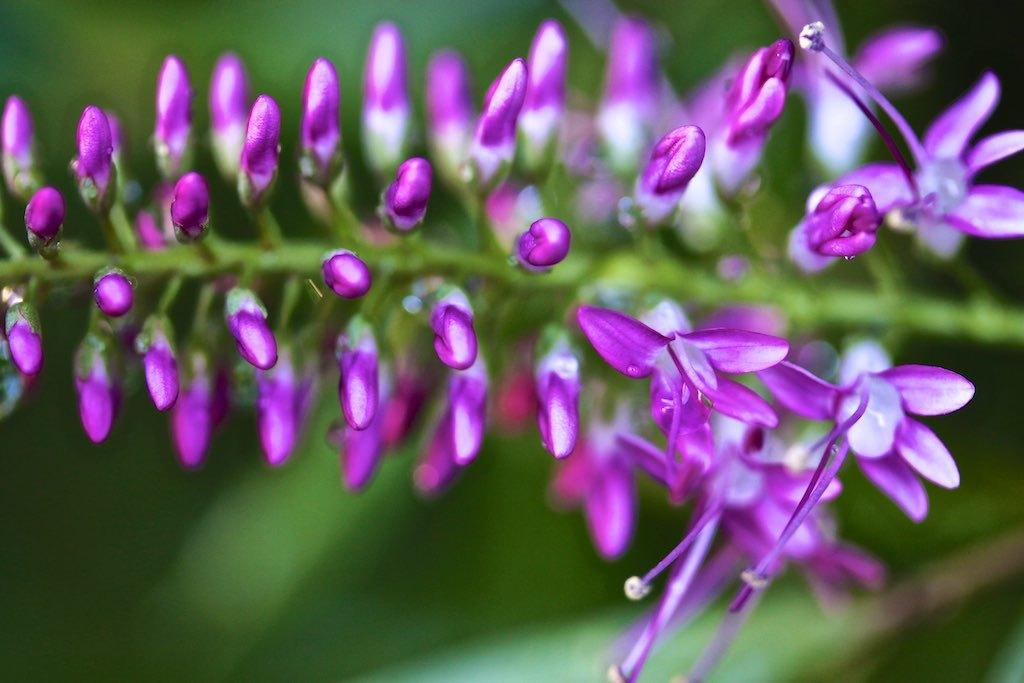What is the main subject in the center of the image? There are flowers and buds in the center of the image. Are there any other objects present in the center of the image? Yes, there are other objects in the center of the image. What color is the background of the image? The background of the image is green in color. What is the sound of people laughing in the image? There is no sound of people laughing in the image, as it is a still image and does not contain any audio. 